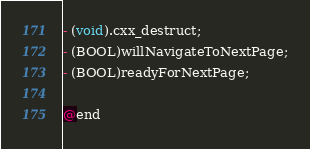Convert code to text. <code><loc_0><loc_0><loc_500><loc_500><_C_>- (void).cxx_destruct;
- (BOOL)willNavigateToNextPage;
- (BOOL)readyForNextPage;

@end

</code> 